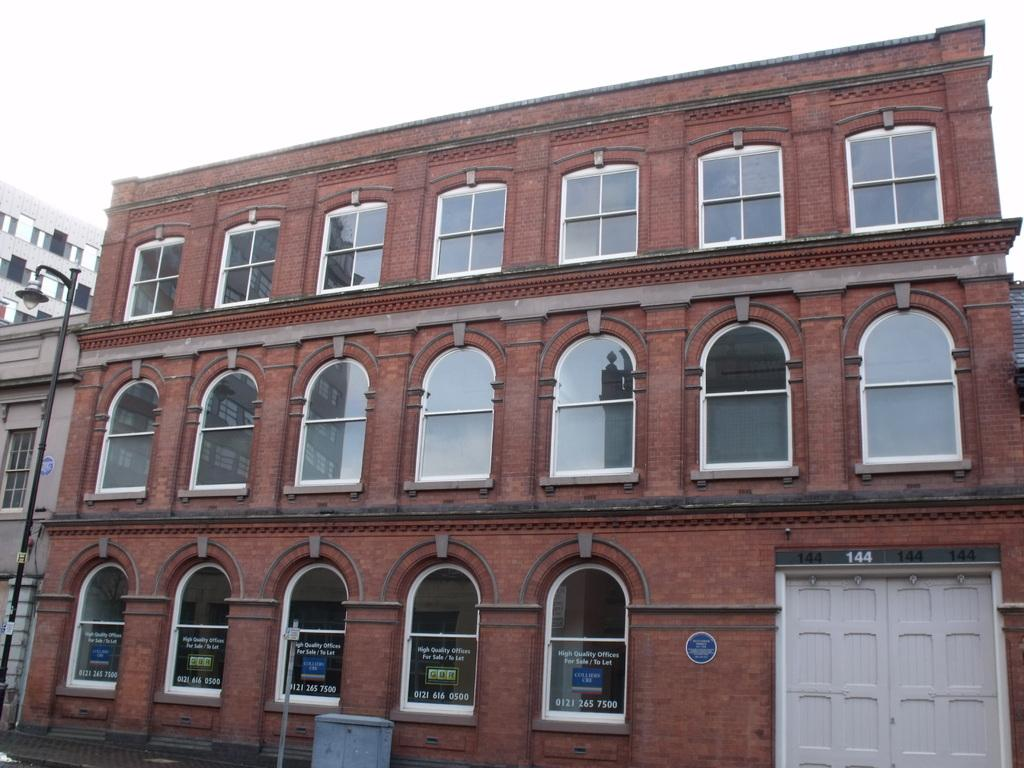What objects are located in the front of the image? There are poles and a bin in the front of the image. What can be seen in the background of the image? There are buildings and a door in the background of the image. Can you describe the door in the background? The door in the background is white in color. What type of texture can be seen on the group of people in the image? There are no people present in the image, so there is no group of people to observe any texture. 